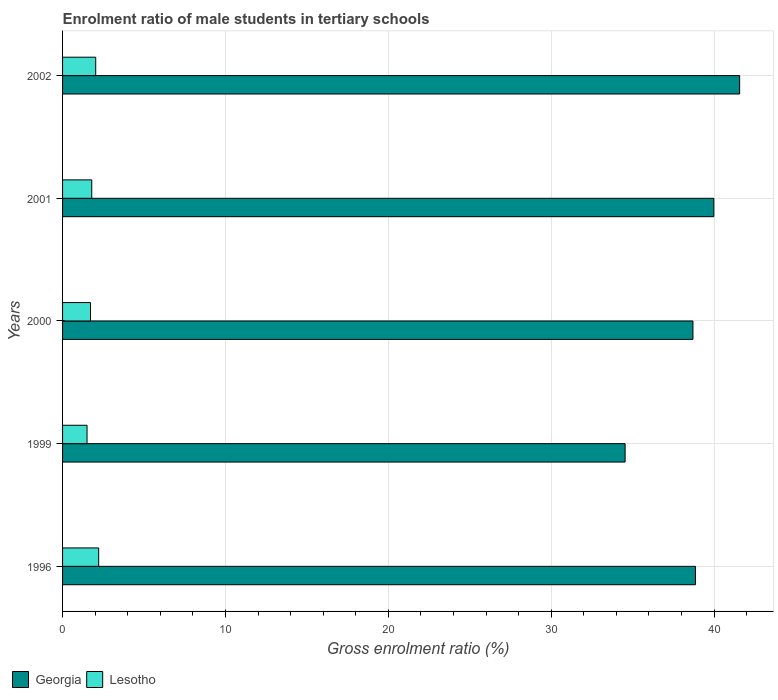How many different coloured bars are there?
Offer a very short reply. 2. How many groups of bars are there?
Offer a very short reply. 5. Are the number of bars per tick equal to the number of legend labels?
Offer a very short reply. Yes. Are the number of bars on each tick of the Y-axis equal?
Offer a very short reply. Yes. How many bars are there on the 5th tick from the top?
Give a very brief answer. 2. How many bars are there on the 5th tick from the bottom?
Make the answer very short. 2. What is the enrolment ratio of male students in tertiary schools in Georgia in 2000?
Your answer should be very brief. 38.7. Across all years, what is the maximum enrolment ratio of male students in tertiary schools in Georgia?
Offer a very short reply. 41.57. Across all years, what is the minimum enrolment ratio of male students in tertiary schools in Lesotho?
Provide a short and direct response. 1.5. What is the total enrolment ratio of male students in tertiary schools in Lesotho in the graph?
Ensure brevity in your answer.  9.26. What is the difference between the enrolment ratio of male students in tertiary schools in Georgia in 1996 and that in 2002?
Make the answer very short. -2.71. What is the difference between the enrolment ratio of male students in tertiary schools in Lesotho in 1996 and the enrolment ratio of male students in tertiary schools in Georgia in 1999?
Give a very brief answer. -32.32. What is the average enrolment ratio of male students in tertiary schools in Lesotho per year?
Make the answer very short. 1.85. In the year 2000, what is the difference between the enrolment ratio of male students in tertiary schools in Lesotho and enrolment ratio of male students in tertiary schools in Georgia?
Provide a short and direct response. -36.98. What is the ratio of the enrolment ratio of male students in tertiary schools in Georgia in 2001 to that in 2002?
Provide a succinct answer. 0.96. What is the difference between the highest and the second highest enrolment ratio of male students in tertiary schools in Georgia?
Your answer should be compact. 1.59. What is the difference between the highest and the lowest enrolment ratio of male students in tertiary schools in Lesotho?
Your answer should be very brief. 0.71. In how many years, is the enrolment ratio of male students in tertiary schools in Lesotho greater than the average enrolment ratio of male students in tertiary schools in Lesotho taken over all years?
Provide a succinct answer. 2. What does the 2nd bar from the top in 2002 represents?
Your answer should be very brief. Georgia. What does the 1st bar from the bottom in 2000 represents?
Your answer should be very brief. Georgia. How many bars are there?
Provide a short and direct response. 10. Are all the bars in the graph horizontal?
Make the answer very short. Yes. Does the graph contain grids?
Provide a short and direct response. Yes. How many legend labels are there?
Offer a very short reply. 2. How are the legend labels stacked?
Ensure brevity in your answer.  Horizontal. What is the title of the graph?
Ensure brevity in your answer.  Enrolment ratio of male students in tertiary schools. Does "Afghanistan" appear as one of the legend labels in the graph?
Keep it short and to the point. No. What is the label or title of the X-axis?
Your answer should be very brief. Gross enrolment ratio (%). What is the label or title of the Y-axis?
Ensure brevity in your answer.  Years. What is the Gross enrolment ratio (%) of Georgia in 1996?
Keep it short and to the point. 38.85. What is the Gross enrolment ratio (%) in Lesotho in 1996?
Give a very brief answer. 2.22. What is the Gross enrolment ratio (%) in Georgia in 1999?
Give a very brief answer. 34.54. What is the Gross enrolment ratio (%) in Lesotho in 1999?
Your response must be concise. 1.5. What is the Gross enrolment ratio (%) of Georgia in 2000?
Your response must be concise. 38.7. What is the Gross enrolment ratio (%) of Lesotho in 2000?
Your response must be concise. 1.72. What is the Gross enrolment ratio (%) in Georgia in 2001?
Offer a very short reply. 39.98. What is the Gross enrolment ratio (%) in Lesotho in 2001?
Give a very brief answer. 1.79. What is the Gross enrolment ratio (%) in Georgia in 2002?
Make the answer very short. 41.57. What is the Gross enrolment ratio (%) in Lesotho in 2002?
Provide a succinct answer. 2.04. Across all years, what is the maximum Gross enrolment ratio (%) in Georgia?
Your answer should be compact. 41.57. Across all years, what is the maximum Gross enrolment ratio (%) in Lesotho?
Offer a terse response. 2.22. Across all years, what is the minimum Gross enrolment ratio (%) of Georgia?
Ensure brevity in your answer.  34.54. Across all years, what is the minimum Gross enrolment ratio (%) of Lesotho?
Ensure brevity in your answer.  1.5. What is the total Gross enrolment ratio (%) in Georgia in the graph?
Your answer should be compact. 193.64. What is the total Gross enrolment ratio (%) of Lesotho in the graph?
Ensure brevity in your answer.  9.26. What is the difference between the Gross enrolment ratio (%) in Georgia in 1996 and that in 1999?
Make the answer very short. 4.32. What is the difference between the Gross enrolment ratio (%) in Lesotho in 1996 and that in 1999?
Your answer should be compact. 0.71. What is the difference between the Gross enrolment ratio (%) of Georgia in 1996 and that in 2000?
Make the answer very short. 0.15. What is the difference between the Gross enrolment ratio (%) in Lesotho in 1996 and that in 2000?
Make the answer very short. 0.5. What is the difference between the Gross enrolment ratio (%) of Georgia in 1996 and that in 2001?
Your answer should be very brief. -1.13. What is the difference between the Gross enrolment ratio (%) of Lesotho in 1996 and that in 2001?
Offer a very short reply. 0.42. What is the difference between the Gross enrolment ratio (%) in Georgia in 1996 and that in 2002?
Ensure brevity in your answer.  -2.71. What is the difference between the Gross enrolment ratio (%) of Lesotho in 1996 and that in 2002?
Make the answer very short. 0.18. What is the difference between the Gross enrolment ratio (%) of Georgia in 1999 and that in 2000?
Provide a succinct answer. -4.16. What is the difference between the Gross enrolment ratio (%) in Lesotho in 1999 and that in 2000?
Your answer should be very brief. -0.21. What is the difference between the Gross enrolment ratio (%) in Georgia in 1999 and that in 2001?
Provide a short and direct response. -5.45. What is the difference between the Gross enrolment ratio (%) in Lesotho in 1999 and that in 2001?
Offer a very short reply. -0.29. What is the difference between the Gross enrolment ratio (%) in Georgia in 1999 and that in 2002?
Your answer should be compact. -7.03. What is the difference between the Gross enrolment ratio (%) of Lesotho in 1999 and that in 2002?
Make the answer very short. -0.53. What is the difference between the Gross enrolment ratio (%) of Georgia in 2000 and that in 2001?
Offer a terse response. -1.28. What is the difference between the Gross enrolment ratio (%) of Lesotho in 2000 and that in 2001?
Make the answer very short. -0.07. What is the difference between the Gross enrolment ratio (%) in Georgia in 2000 and that in 2002?
Make the answer very short. -2.87. What is the difference between the Gross enrolment ratio (%) of Lesotho in 2000 and that in 2002?
Offer a terse response. -0.32. What is the difference between the Gross enrolment ratio (%) of Georgia in 2001 and that in 2002?
Ensure brevity in your answer.  -1.58. What is the difference between the Gross enrolment ratio (%) of Lesotho in 2001 and that in 2002?
Provide a short and direct response. -0.24. What is the difference between the Gross enrolment ratio (%) of Georgia in 1996 and the Gross enrolment ratio (%) of Lesotho in 1999?
Your answer should be very brief. 37.35. What is the difference between the Gross enrolment ratio (%) of Georgia in 1996 and the Gross enrolment ratio (%) of Lesotho in 2000?
Offer a very short reply. 37.14. What is the difference between the Gross enrolment ratio (%) of Georgia in 1996 and the Gross enrolment ratio (%) of Lesotho in 2001?
Your answer should be compact. 37.06. What is the difference between the Gross enrolment ratio (%) in Georgia in 1996 and the Gross enrolment ratio (%) in Lesotho in 2002?
Offer a terse response. 36.82. What is the difference between the Gross enrolment ratio (%) in Georgia in 1999 and the Gross enrolment ratio (%) in Lesotho in 2000?
Provide a succinct answer. 32.82. What is the difference between the Gross enrolment ratio (%) of Georgia in 1999 and the Gross enrolment ratio (%) of Lesotho in 2001?
Ensure brevity in your answer.  32.74. What is the difference between the Gross enrolment ratio (%) in Georgia in 1999 and the Gross enrolment ratio (%) in Lesotho in 2002?
Your answer should be very brief. 32.5. What is the difference between the Gross enrolment ratio (%) in Georgia in 2000 and the Gross enrolment ratio (%) in Lesotho in 2001?
Make the answer very short. 36.91. What is the difference between the Gross enrolment ratio (%) in Georgia in 2000 and the Gross enrolment ratio (%) in Lesotho in 2002?
Keep it short and to the point. 36.67. What is the difference between the Gross enrolment ratio (%) in Georgia in 2001 and the Gross enrolment ratio (%) in Lesotho in 2002?
Your response must be concise. 37.95. What is the average Gross enrolment ratio (%) in Georgia per year?
Offer a very short reply. 38.73. What is the average Gross enrolment ratio (%) of Lesotho per year?
Your answer should be compact. 1.85. In the year 1996, what is the difference between the Gross enrolment ratio (%) in Georgia and Gross enrolment ratio (%) in Lesotho?
Offer a very short reply. 36.64. In the year 1999, what is the difference between the Gross enrolment ratio (%) of Georgia and Gross enrolment ratio (%) of Lesotho?
Your answer should be compact. 33.03. In the year 2000, what is the difference between the Gross enrolment ratio (%) in Georgia and Gross enrolment ratio (%) in Lesotho?
Provide a short and direct response. 36.98. In the year 2001, what is the difference between the Gross enrolment ratio (%) in Georgia and Gross enrolment ratio (%) in Lesotho?
Provide a short and direct response. 38.19. In the year 2002, what is the difference between the Gross enrolment ratio (%) in Georgia and Gross enrolment ratio (%) in Lesotho?
Offer a very short reply. 39.53. What is the ratio of the Gross enrolment ratio (%) of Lesotho in 1996 to that in 1999?
Ensure brevity in your answer.  1.48. What is the ratio of the Gross enrolment ratio (%) in Georgia in 1996 to that in 2000?
Keep it short and to the point. 1. What is the ratio of the Gross enrolment ratio (%) in Lesotho in 1996 to that in 2000?
Offer a terse response. 1.29. What is the ratio of the Gross enrolment ratio (%) in Georgia in 1996 to that in 2001?
Your answer should be compact. 0.97. What is the ratio of the Gross enrolment ratio (%) of Lesotho in 1996 to that in 2001?
Offer a terse response. 1.24. What is the ratio of the Gross enrolment ratio (%) of Georgia in 1996 to that in 2002?
Your answer should be compact. 0.93. What is the ratio of the Gross enrolment ratio (%) in Lesotho in 1996 to that in 2002?
Offer a very short reply. 1.09. What is the ratio of the Gross enrolment ratio (%) of Georgia in 1999 to that in 2000?
Give a very brief answer. 0.89. What is the ratio of the Gross enrolment ratio (%) in Lesotho in 1999 to that in 2000?
Your answer should be compact. 0.88. What is the ratio of the Gross enrolment ratio (%) in Georgia in 1999 to that in 2001?
Ensure brevity in your answer.  0.86. What is the ratio of the Gross enrolment ratio (%) in Lesotho in 1999 to that in 2001?
Your response must be concise. 0.84. What is the ratio of the Gross enrolment ratio (%) of Georgia in 1999 to that in 2002?
Ensure brevity in your answer.  0.83. What is the ratio of the Gross enrolment ratio (%) in Lesotho in 1999 to that in 2002?
Ensure brevity in your answer.  0.74. What is the ratio of the Gross enrolment ratio (%) of Georgia in 2000 to that in 2001?
Offer a terse response. 0.97. What is the ratio of the Gross enrolment ratio (%) of Lesotho in 2000 to that in 2001?
Your answer should be compact. 0.96. What is the ratio of the Gross enrolment ratio (%) of Lesotho in 2000 to that in 2002?
Your answer should be compact. 0.84. What is the ratio of the Gross enrolment ratio (%) in Georgia in 2001 to that in 2002?
Provide a short and direct response. 0.96. What is the ratio of the Gross enrolment ratio (%) of Lesotho in 2001 to that in 2002?
Provide a succinct answer. 0.88. What is the difference between the highest and the second highest Gross enrolment ratio (%) of Georgia?
Ensure brevity in your answer.  1.58. What is the difference between the highest and the second highest Gross enrolment ratio (%) of Lesotho?
Make the answer very short. 0.18. What is the difference between the highest and the lowest Gross enrolment ratio (%) of Georgia?
Give a very brief answer. 7.03. What is the difference between the highest and the lowest Gross enrolment ratio (%) in Lesotho?
Make the answer very short. 0.71. 